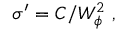Convert formula to latex. <formula><loc_0><loc_0><loc_500><loc_500>\sigma ^ { \prime } = C / W _ { \phi } ^ { 2 } ,</formula> 